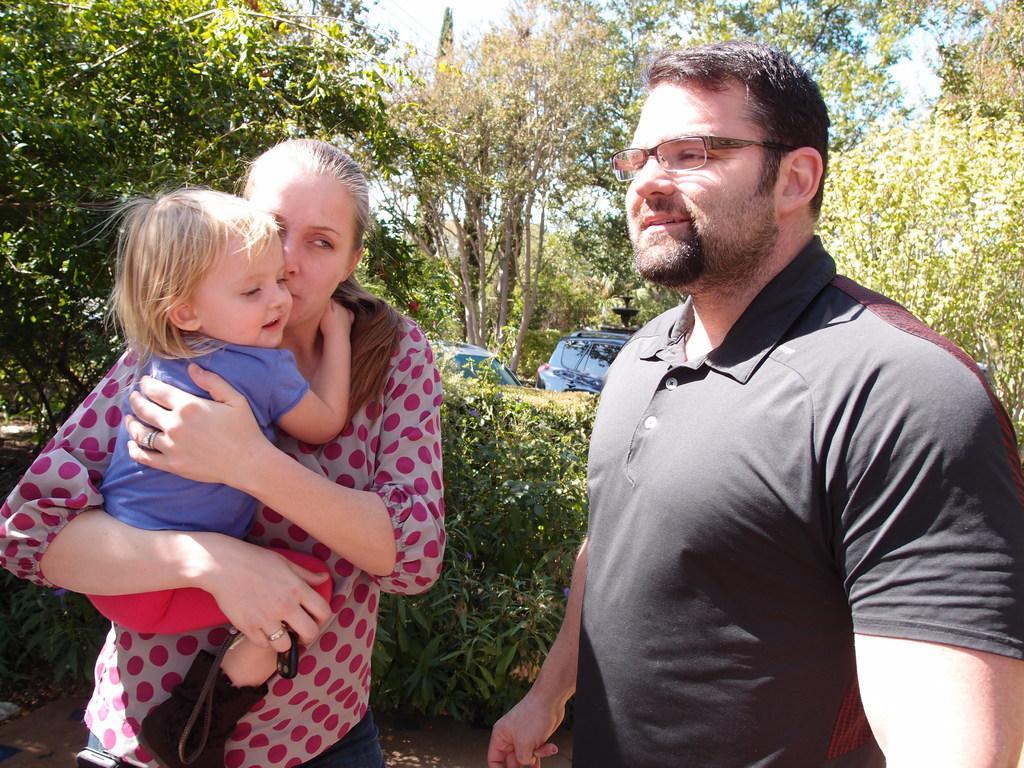Could you give a brief overview of what you see in this image? This picture is clicked outside. On the right we can see a man wearing black color t-shirt and seems to be standing. On the left we can see a person carrying a kid and holding some object and standing. In the background we can see the sky, trees, vehicles, plants and some other objects. 